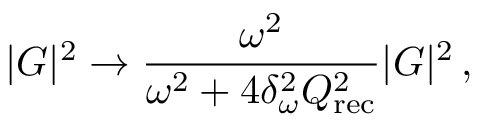<formula> <loc_0><loc_0><loc_500><loc_500>| G | ^ { 2 } \rightarrow \frac { \omega ^ { 2 } } { \omega ^ { 2 } + 4 \delta _ { \omega } ^ { 2 } Q _ { r e c } ^ { 2 } } | G | ^ { 2 } \, ,</formula> 